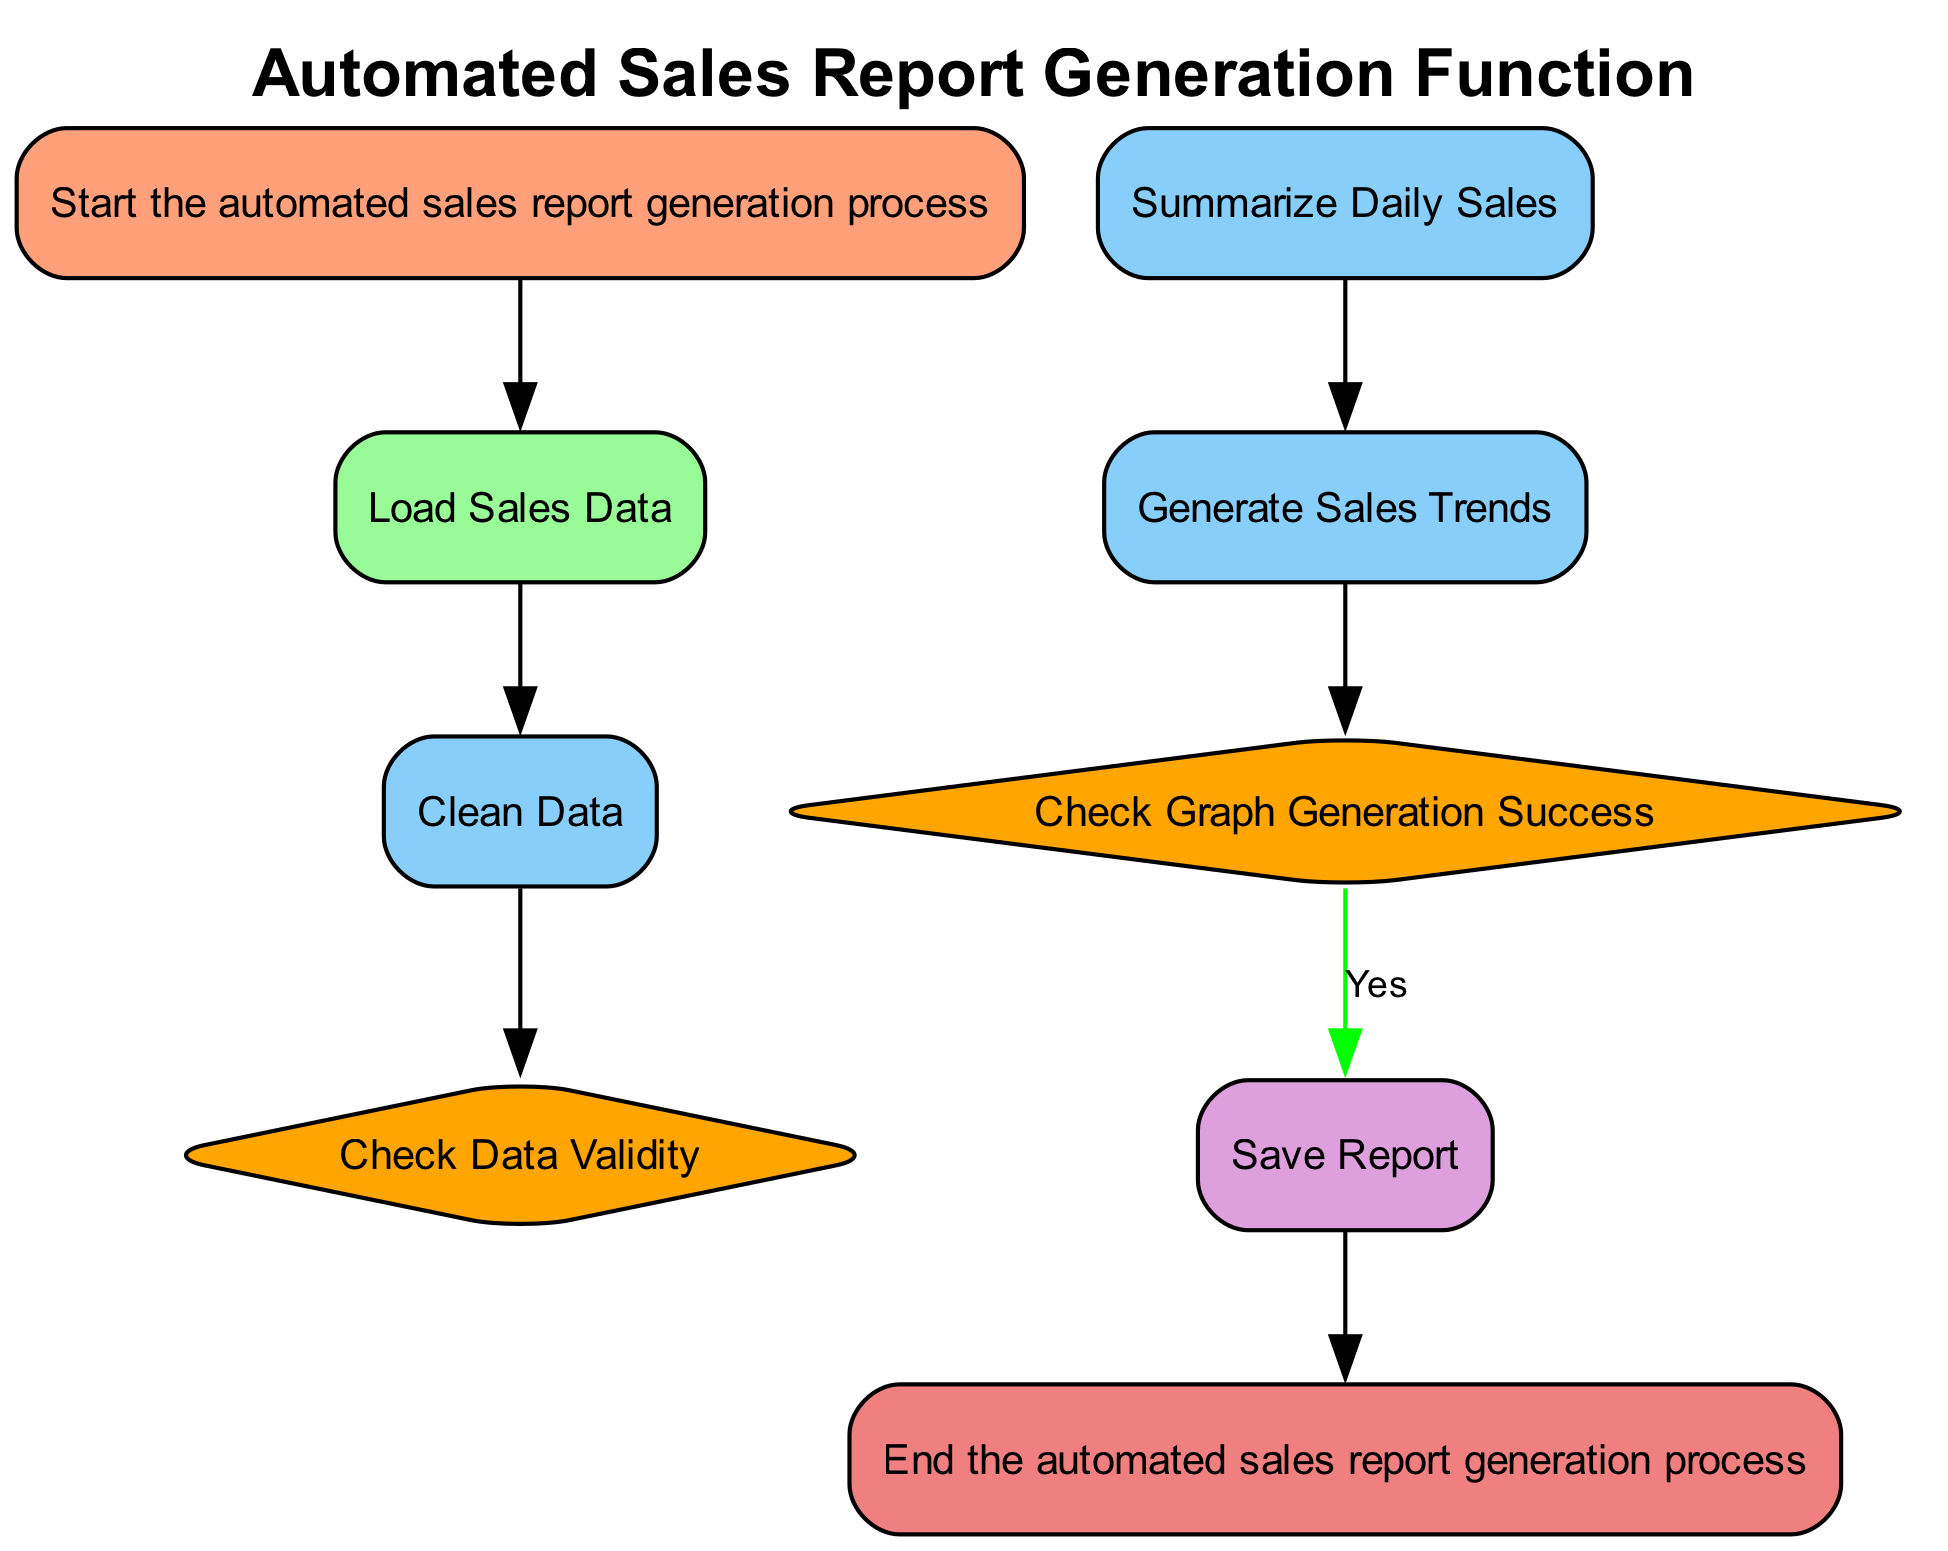What is the first step in the flowchart? The diagram starts with the "Start the automated sales report generation process" node, indicating it is the beginning of the flow.
Answer: Start the automated sales report generation process How many decision nodes are present in the flowchart? Upon examining the diagram, there are two decision nodes: "Check Data Validity" and "Check Graph Generation Success."
Answer: 2 What is saved at the end of the automated sales report generation process? The output process node indicates that the sales report is saved as "sales_report.pdf" in the "reports" directory.
Answer: sales_report.pdf What happens if the sales data does not meet quality standards? The flowchart indicates that if the sales data fails the validity check, the process will log an error and stop.
Answer: Log Error and Stop What is the output node's type in the flowchart? The output node is represented in the diagram as "Output," which indicates the process of saving the report. This confirms the functionality of the output operation in the context of the flowchart.
Answer: Output 